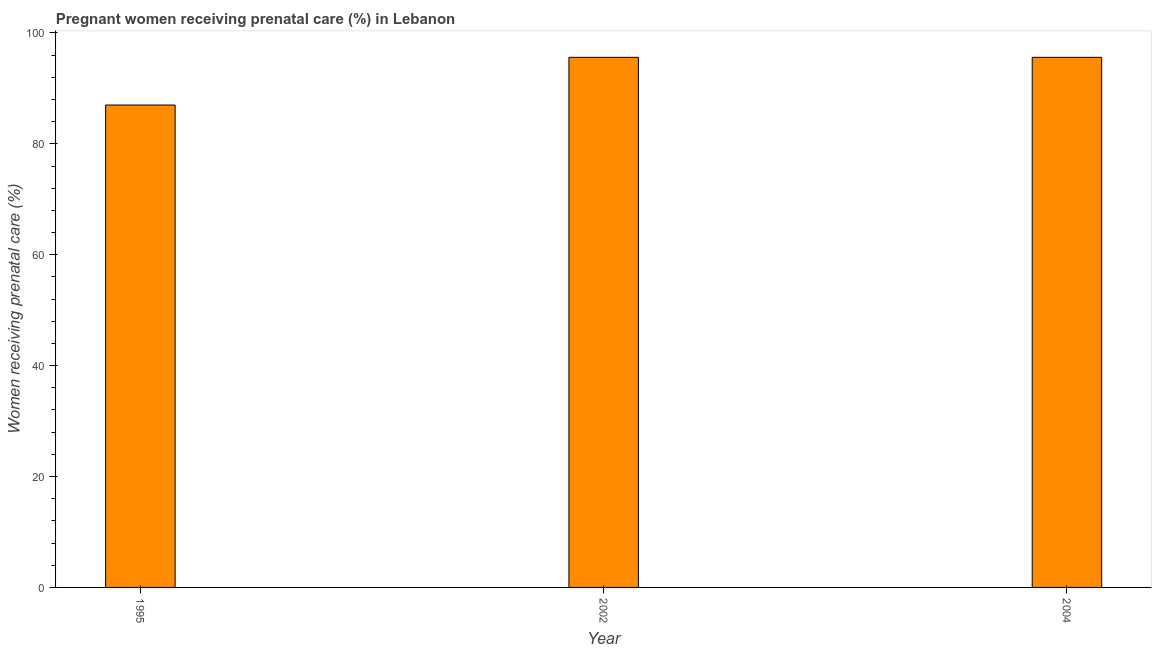Does the graph contain grids?
Offer a very short reply. No. What is the title of the graph?
Your response must be concise. Pregnant women receiving prenatal care (%) in Lebanon. What is the label or title of the Y-axis?
Offer a very short reply. Women receiving prenatal care (%). What is the percentage of pregnant women receiving prenatal care in 2002?
Ensure brevity in your answer.  95.6. Across all years, what is the maximum percentage of pregnant women receiving prenatal care?
Provide a short and direct response. 95.6. In which year was the percentage of pregnant women receiving prenatal care maximum?
Provide a succinct answer. 2002. In which year was the percentage of pregnant women receiving prenatal care minimum?
Give a very brief answer. 1995. What is the sum of the percentage of pregnant women receiving prenatal care?
Offer a terse response. 278.2. What is the average percentage of pregnant women receiving prenatal care per year?
Offer a very short reply. 92.73. What is the median percentage of pregnant women receiving prenatal care?
Provide a succinct answer. 95.6. In how many years, is the percentage of pregnant women receiving prenatal care greater than 64 %?
Provide a short and direct response. 3. Do a majority of the years between 2002 and 2004 (inclusive) have percentage of pregnant women receiving prenatal care greater than 48 %?
Keep it short and to the point. Yes. What is the ratio of the percentage of pregnant women receiving prenatal care in 2002 to that in 2004?
Keep it short and to the point. 1. Is the difference between the percentage of pregnant women receiving prenatal care in 1995 and 2002 greater than the difference between any two years?
Your answer should be compact. Yes. Are the values on the major ticks of Y-axis written in scientific E-notation?
Provide a succinct answer. No. What is the Women receiving prenatal care (%) in 1995?
Give a very brief answer. 87. What is the Women receiving prenatal care (%) of 2002?
Provide a succinct answer. 95.6. What is the Women receiving prenatal care (%) of 2004?
Your answer should be compact. 95.6. What is the difference between the Women receiving prenatal care (%) in 1995 and 2002?
Ensure brevity in your answer.  -8.6. What is the difference between the Women receiving prenatal care (%) in 1995 and 2004?
Offer a very short reply. -8.6. What is the difference between the Women receiving prenatal care (%) in 2002 and 2004?
Your response must be concise. 0. What is the ratio of the Women receiving prenatal care (%) in 1995 to that in 2002?
Keep it short and to the point. 0.91. What is the ratio of the Women receiving prenatal care (%) in 1995 to that in 2004?
Ensure brevity in your answer.  0.91. 